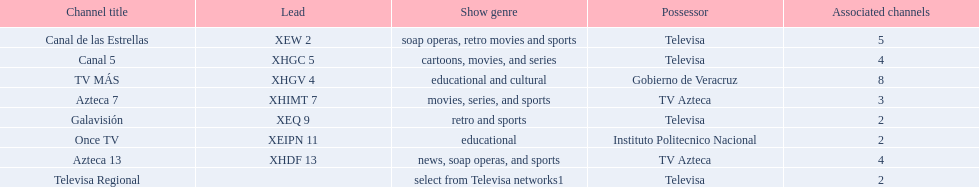In comparison to canal de las estrellas, how many networks are there with more affiliates? 1. 